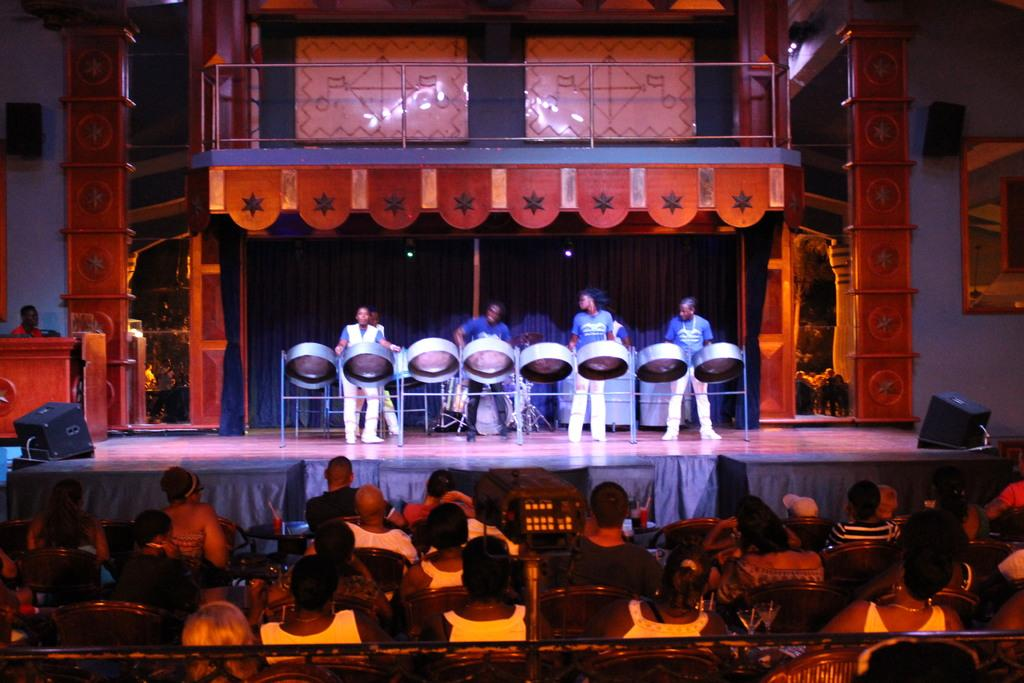What are the people in the image doing? There is a group of people sitting on chairs and another group playing musical instruments in the image. What might be used to amplify the sound of the musical instruments? There are speakers in the image. What other objects can be seen in the image? There are other objects present in the image, but their specific details are not mentioned in the provided facts. How many beds can be seen in the image? There are no beds present in the image. Is there any blood visible in the image? There is no blood visible in the image. 